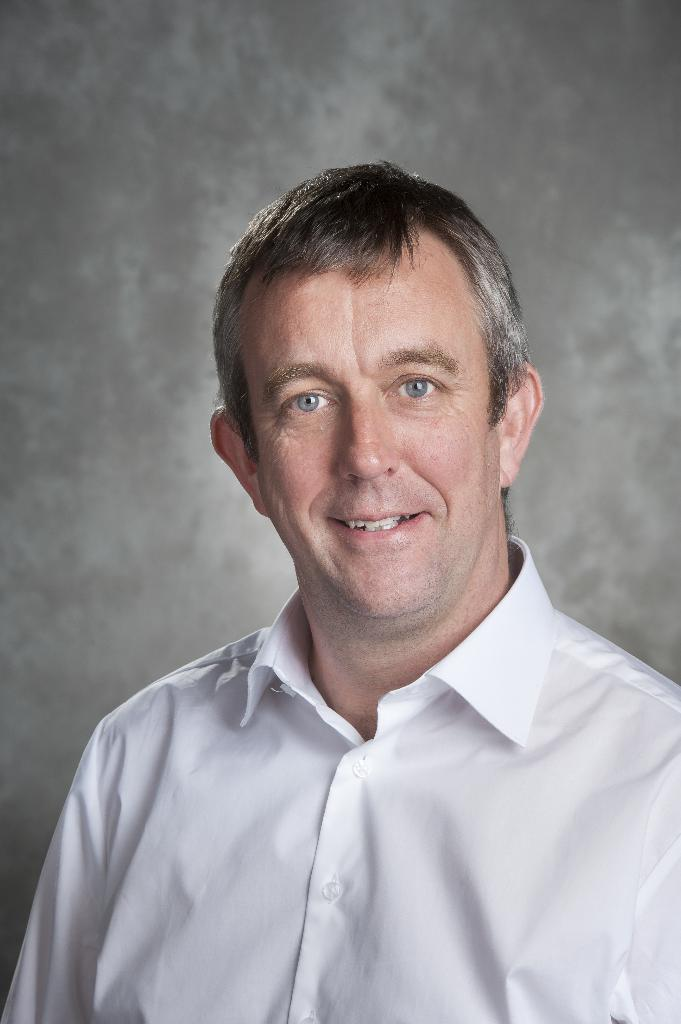Where was the image taken? The image was taken indoors. What can be seen in the background of the image? There is a wall in the background of the image. Who is the main subject in the image? There is a man in the middle of the image. What is the man's facial expression? The man has a smiling face. What type of suit is the man wearing in the image? The image does not show the man wearing a suit; he is not dressed in any specific attire. Can you tell me how many calculators are visible in the image? There are no calculators present in the image. 